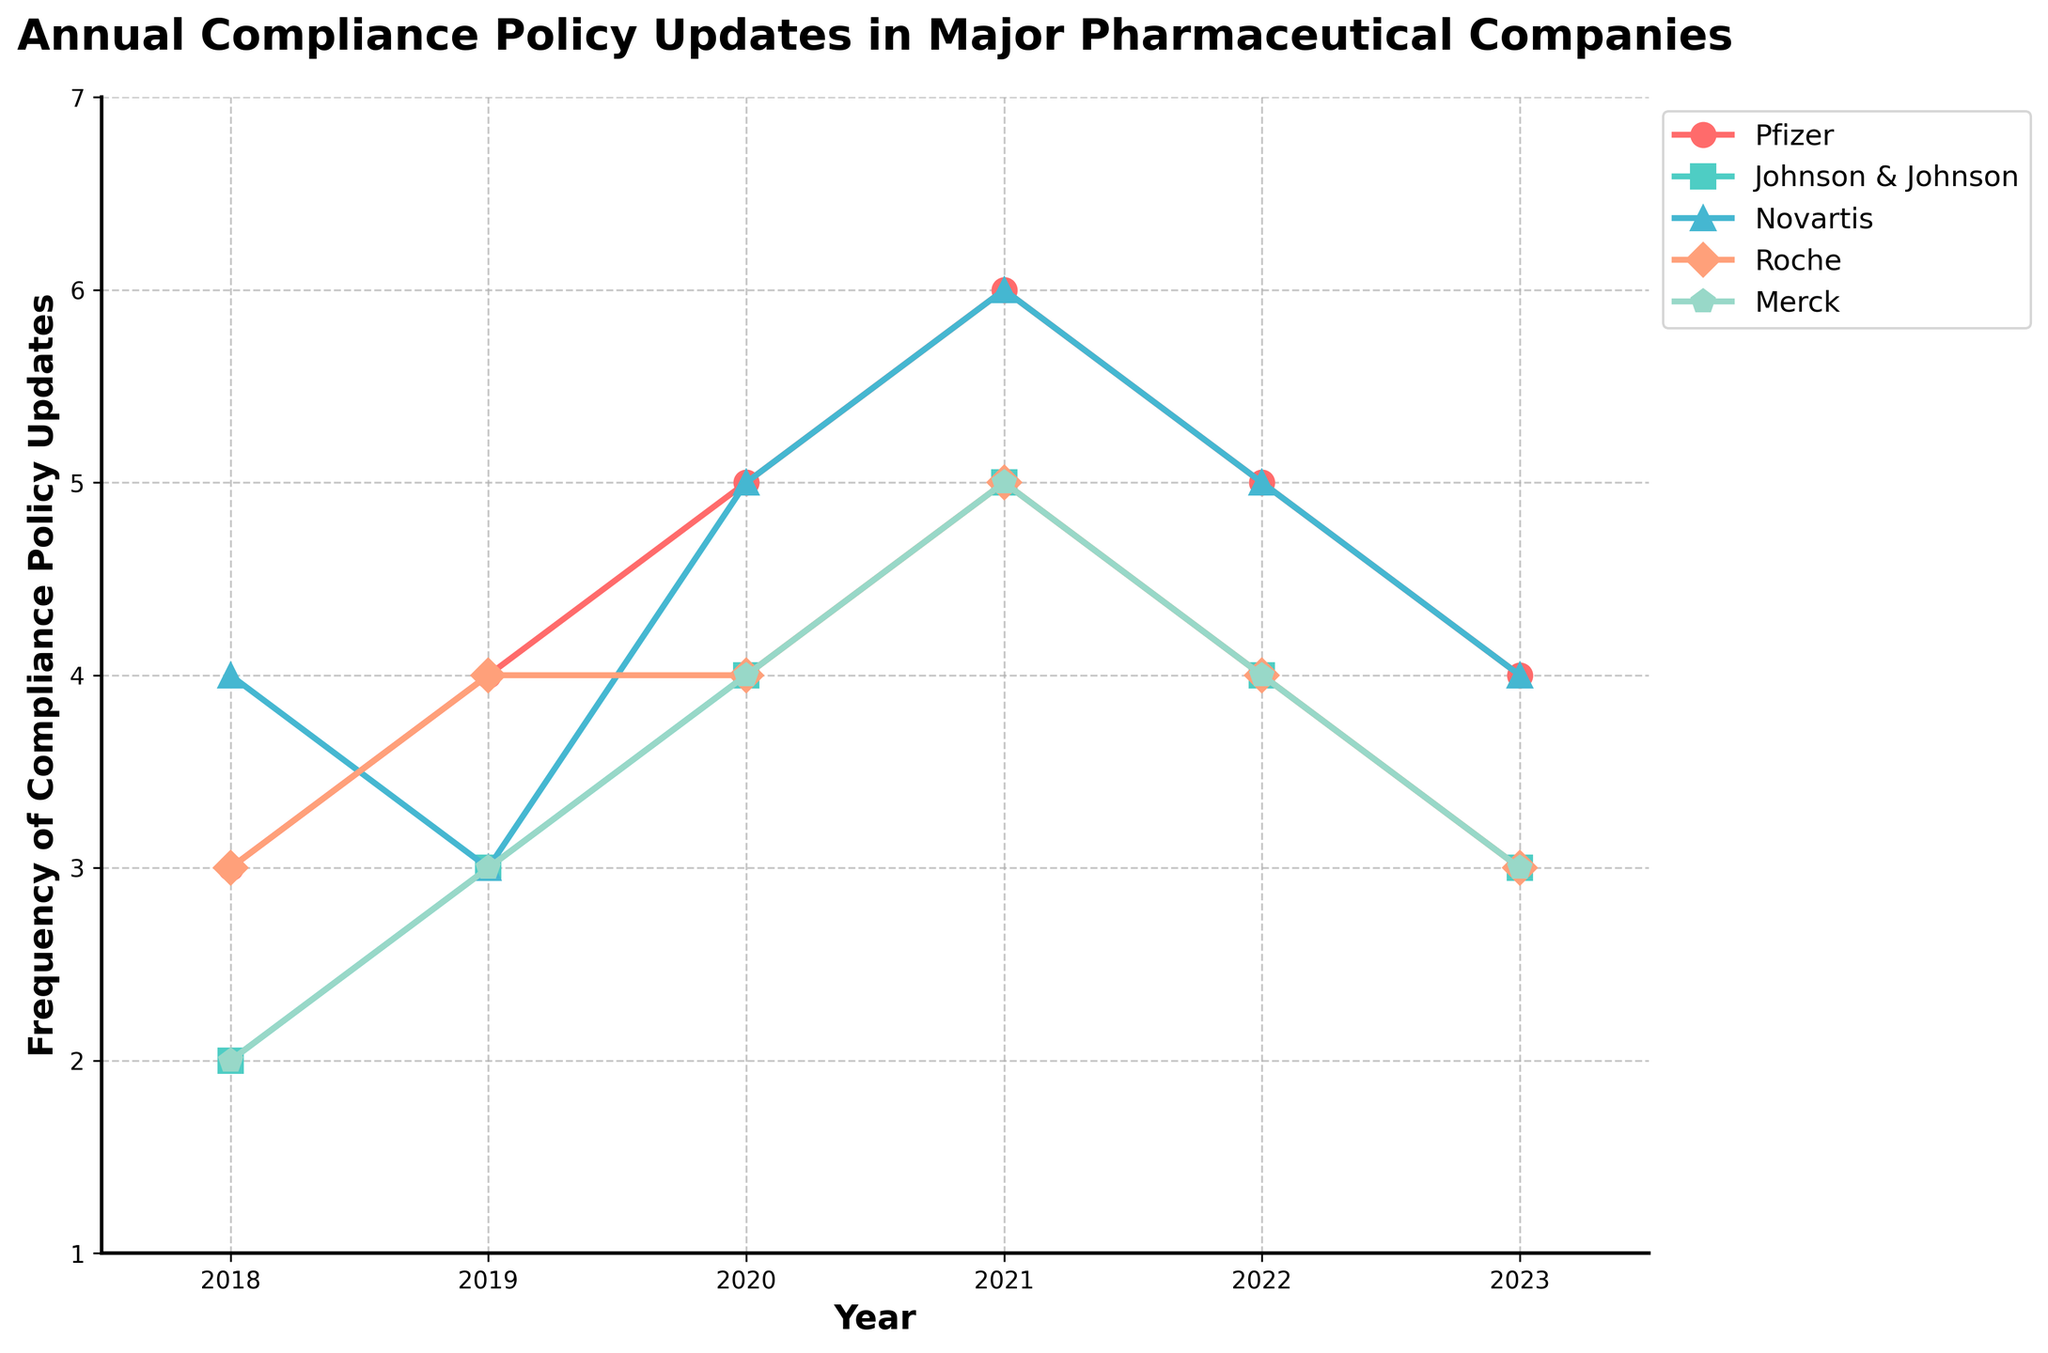What year did Pfizer reach its highest frequency of compliance policy updates? Look at the line for Pfizer (red line) and find the peak point. The peak occurs in 2021 with 6 updates.
Answer: 2021 Which company saw the most significant increase in compliance policy updates between 2018 and 2021? Compare the values for each company between 2018 and 2021 and find the highest difference: Pfizer (3 to 6), Johnson & Johnson (2 to 5), Novartis (4 to 6), Roche (3 to 5), Merck (2 to 5). The most significant increase is for Pfizer.
Answer: Pfizer What is the average frequency of compliance policy updates for Merck from 2018 to 2023? Sum the frequencies for Merck from 2018 to 2023 (2 + 3 + 4 + 5 + 4 + 3 = 21) and divide by the number of years (6).
Answer: 3.5 In which year did Johnson & Johnson and Roche have the same number of compliance policy updates? Look at the lines for Johnson & Johnson (green line) and Roche (orange line) to find where they coincide. They coincide in 2018, 2020, and 2023 with 2, 4, and 3 updates, respectively.
Answer: 2018, 2020, 2023 Was there any year in which Novartis had fewer compliance policy updates than any other company? Compare the number of updates for Novartis with all other companies for all years. Novartis always had equal or more updates than at least one other company.
Answer: No Which company had the least variation in the frequency of updates over the years? Calculate the range (maximum - minimum) for each company: Pfizer (6 - 3 = 3), Johnson & Johnson (5 - 2 = 3), Novartis (6 - 4 = 2), Roche (5 - 3 = 2), Merck (5 - 2 = 3). The least variation is for Novartis and Roche.
Answer: Novartis, Roche How did the frequency of compliance policy updates change for Roche between 2020 and 2023? Look at the number of updates for Roche (orange line) from 2020 to 2023: 4 in 2020, 5 in 2021, 4 in 2022, and 3 in 2023, showing fluctuations around a peak of 5 in 2021 to a decline.
Answer: Fluctuated and decreased What is the combined frequency of compliance policy updates for Pfizer and Johnson & Johnson in 2021? Add the number of updates for Pfizer and Johnson & Johnson in 2021: 6 (Pfizer) + 5 (Johnson & Johnson) = 11.
Answer: 11 In which years did all companies have the same number of compliance policy updates? Look for years where all lines (companies) meet at the same value, which does not occur in any year.
Answer: None Which company updated its compliance policies the most frequently over the entire period? Sum the total updates for each company from 2018 to 2023, then compare: Pfizer (25), Johnson & Johnson (21), Novartis (27), Roche (23), Merck (21). The highest total is for Novartis.
Answer: Novartis 